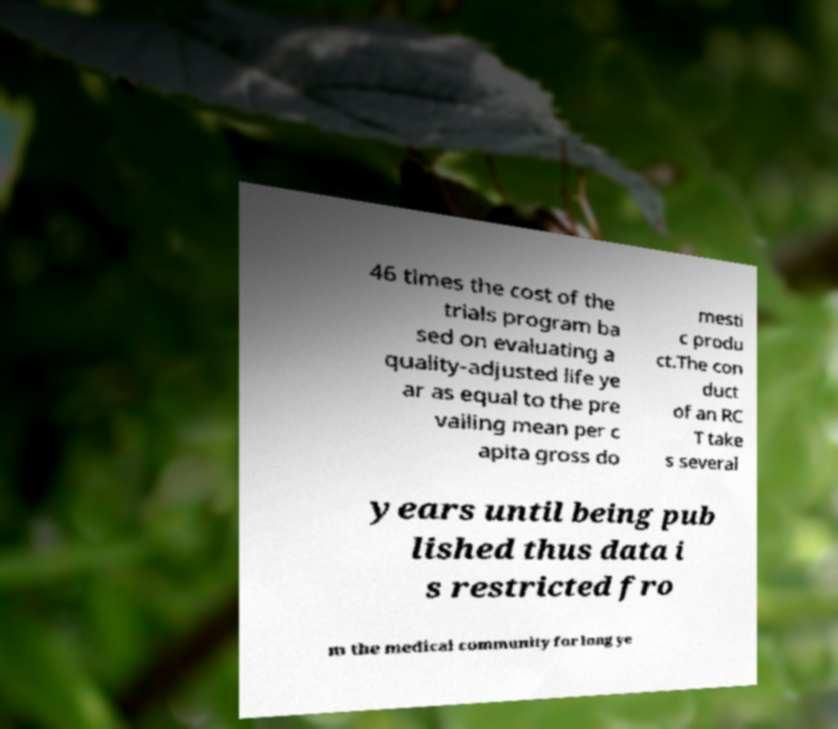I need the written content from this picture converted into text. Can you do that? 46 times the cost of the trials program ba sed on evaluating a quality-adjusted life ye ar as equal to the pre vailing mean per c apita gross do mesti c produ ct.The con duct of an RC T take s several years until being pub lished thus data i s restricted fro m the medical community for long ye 